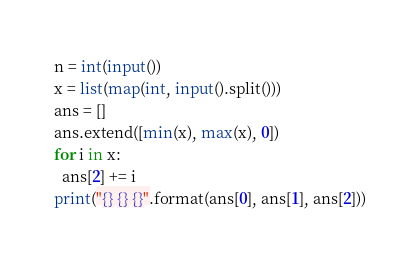<code> <loc_0><loc_0><loc_500><loc_500><_Python_>n = int(input())
x = list(map(int, input().split()))
ans = []
ans.extend([min(x), max(x), 0])
for i in x:
  ans[2] += i
print("{} {} {}".format(ans[0], ans[1], ans[2]))
</code> 